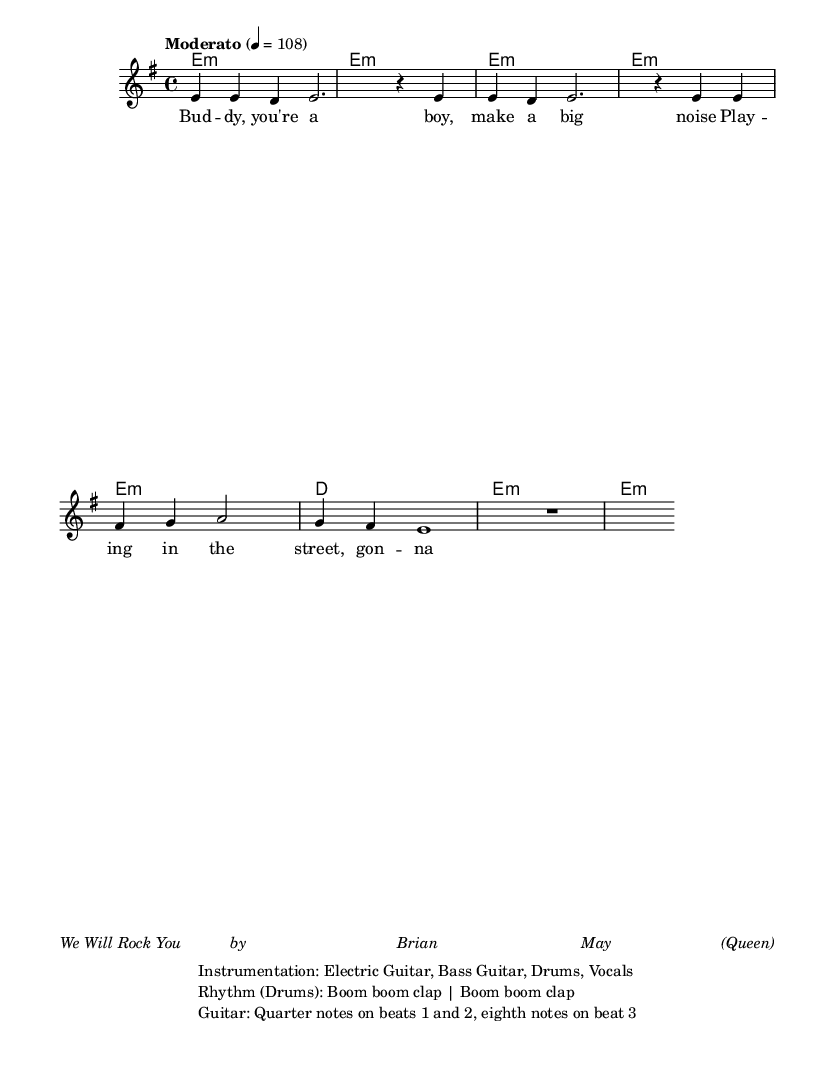What is the key signature of this music? The key signature shown indicates E minor, which has one sharp (F#). This is derived from the global section of the sheet music where the key is stated.
Answer: E minor What is the time signature of the piece? The time signature represented at the beginning of the score is 4/4, which means there are four beats in each measure and the quarter note gets one beat.
Answer: 4/4 What is the tempo marking for this piece? The sheet music specifies the tempo as "Moderato" with a metronome marking of 108, indicating a moderate pace. This is also found in the global section.
Answer: Moderato, 108 How many measures are there in the melody? By counting the number of bars indicated in the melody section, there are a total of 8 measures. Each bar is separated by a vertical line.
Answer: 8 What type of instrumentation is used in this piece? The instrumentation listed includes electric guitar, bass guitar, drums, and vocals. This information is provided in the markup section below the music.
Answer: Electric Guitar, Bass Guitar, Drums, Vocals What rhythmic pattern is evident in the drums? The rhythmic pattern described for the drums is "Boom boom clap," which denotes a strong beat played twice followed by a clap, reflecting the rhythmic structure in the song.
Answer: Boom boom clap What is the primary lyrical theme conveyed in the verse? The verse conveys a narrative of aspiration and striving for success, with the lyrics mentioning being a "big man someday," highlighting a journey towards achievement.
Answer: Aspiration and striving 